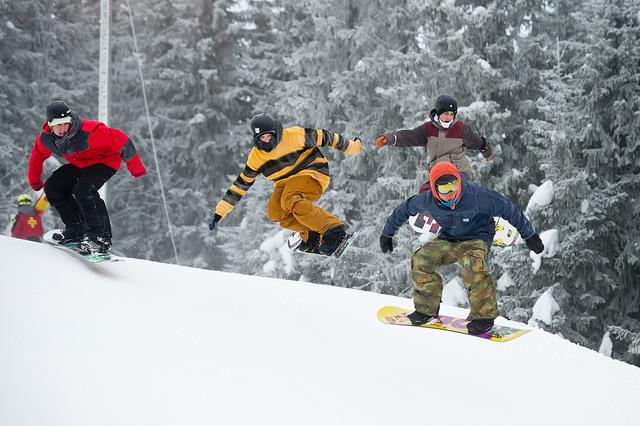The middle athlete looks like an what?

Choices:
A) shark
B) dog
C) bee
D) horse bee 